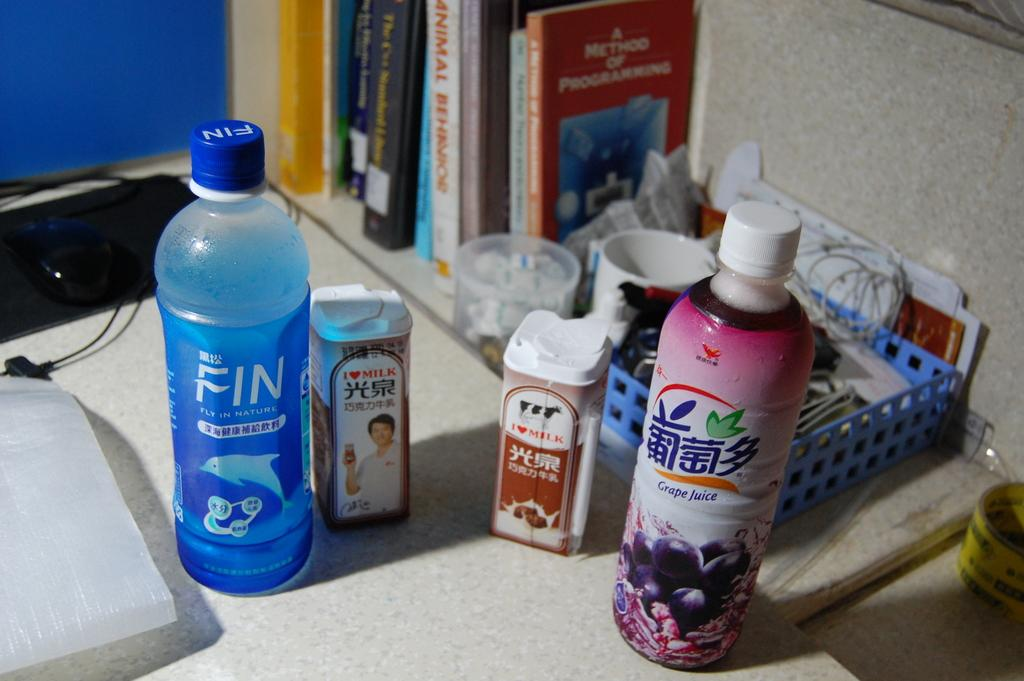<image>
Offer a succinct explanation of the picture presented. Tall bottle of Grape Juice next to a blue box. 